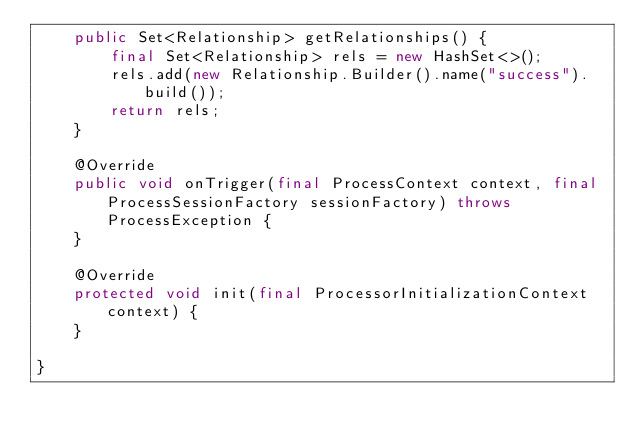<code> <loc_0><loc_0><loc_500><loc_500><_Java_>    public Set<Relationship> getRelationships() {
        final Set<Relationship> rels = new HashSet<>();
        rels.add(new Relationship.Builder().name("success").build());
        return rels;
    }

    @Override
    public void onTrigger(final ProcessContext context, final ProcessSessionFactory sessionFactory) throws ProcessException {
    }

    @Override
    protected void init(final ProcessorInitializationContext context) {
    }

}
</code> 